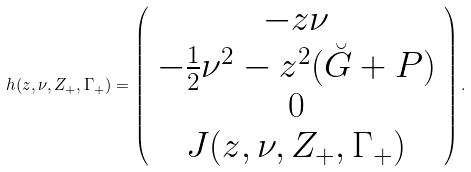<formula> <loc_0><loc_0><loc_500><loc_500>h ( z , \nu , Z _ { + } , \Gamma _ { + } ) = \left ( \begin{array} { c } - z \nu \\ - \frac { 1 } { 2 } \nu ^ { 2 } - z ^ { 2 } ( \breve { G } + P ) \\ 0 \\ J ( z , \nu , Z _ { + } , \Gamma _ { + } ) \end{array} \right ) .</formula> 